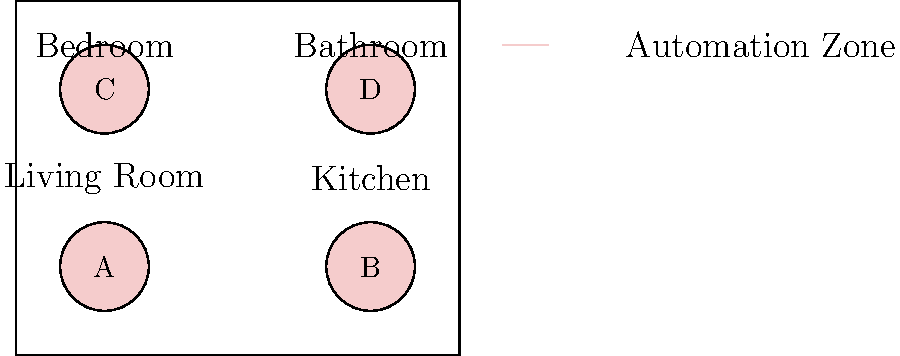In the smart home floor plan shown, four automation zones (A, B, C, and D) are highlighted. Which zone would be most appropriate for implementing an automated lighting system that adjusts based on natural light levels and occupancy? To determine the most appropriate zone for implementing an automated lighting system that adjusts based on natural light levels and occupancy, we need to consider the following factors:

1. Room function: Different rooms have different lighting needs.
2. Potential for natural light: Rooms with more windows or external walls are more affected by natural light.
3. Occupancy patterns: Areas with variable occupancy benefit more from occupancy-based lighting control.

Let's analyze each zone:

A. Living Room: 
   - Often has large windows for natural light
   - Variable occupancy throughout the day
   - Requires flexible lighting for different activities

B. Kitchen:
   - May have some natural light, but often needs consistent artificial lighting
   - Occupancy can be frequent but intermittent
   - Task-specific lighting is often more important than ambient light control

C. Bedroom:
   - Natural light is important, but privacy may limit window size
   - Occupancy is more predictable (mainly nighttime and mornings)
   - Gradual light adjustments are beneficial for wake-up routines

D. Bathroom:
   - Often has limited natural light
   - Occupancy is typically short-term and intermittent
   - Consistent lighting is usually more important than dynamic adjustments

Considering these factors, the Living Room (Zone A) would benefit most from an automated lighting system that adjusts based on natural light levels and occupancy. It has the highest potential for natural light variation, the most diverse occupancy patterns, and the greatest need for flexible lighting conditions.
Answer: Zone A (Living Room) 